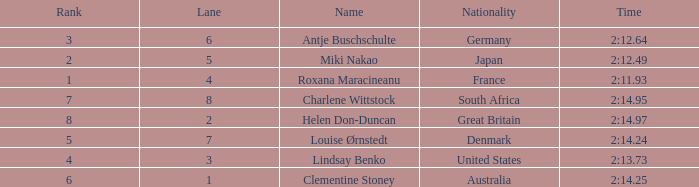What shows for nationality when there is a rank larger than 6, and a Time of 2:14.95? South Africa. 